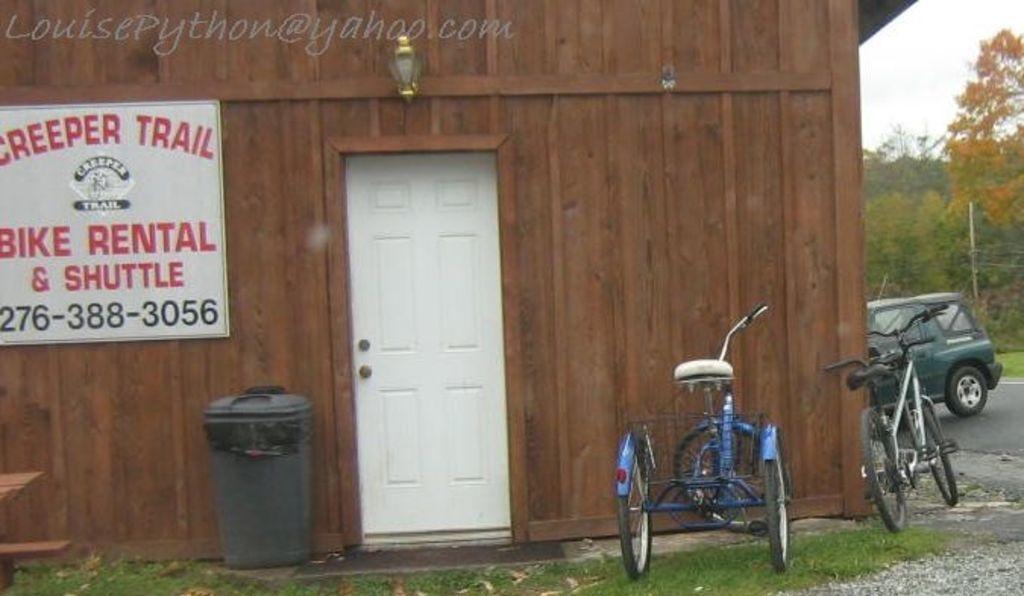In one or two sentences, can you explain what this image depicts? We can see bicycles, car, road, grass and dust bin. We can see board on a wooden wall and door. In the background we can see pole, trees and sky. 